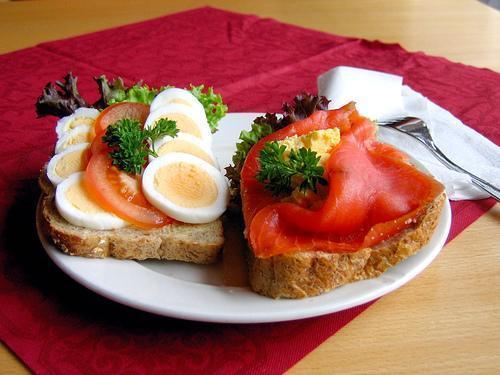How many pieces of bread are visible?
Give a very brief answer. 2. How many utensils are visible?
Give a very brief answer. 1. How many sandwiches are there?
Give a very brief answer. 2. 